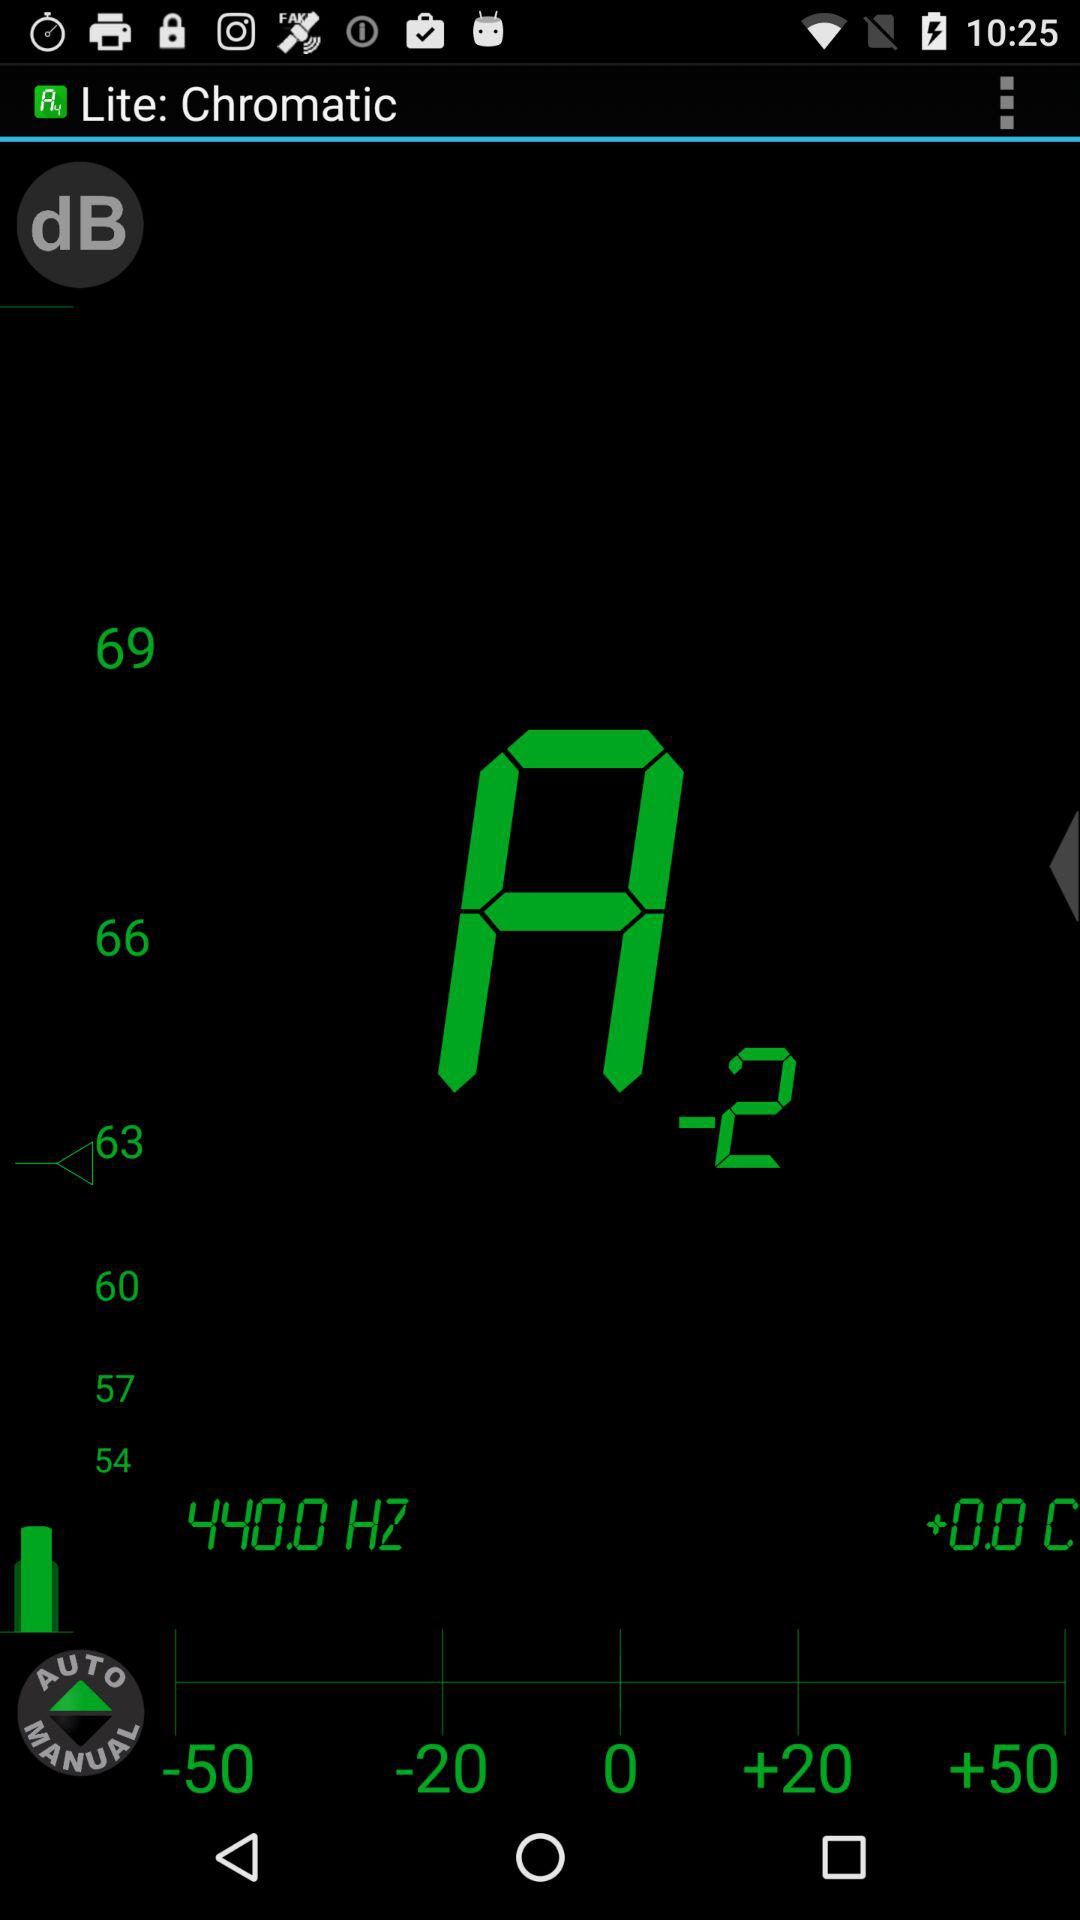How many more dB is the sound level at 66 dB than at 50 dB?
Answer the question using a single word or phrase. 16 